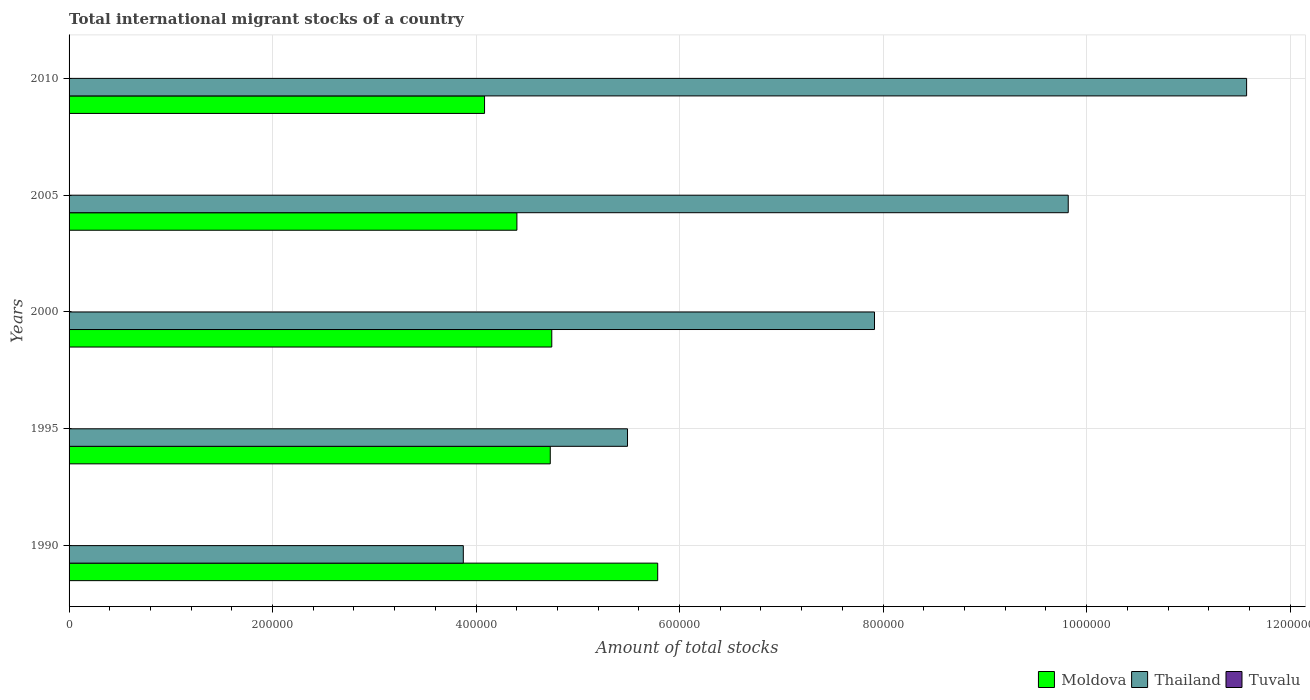How many different coloured bars are there?
Offer a terse response. 3. How many bars are there on the 4th tick from the top?
Your answer should be very brief. 3. How many bars are there on the 1st tick from the bottom?
Give a very brief answer. 3. What is the label of the 5th group of bars from the top?
Give a very brief answer. 1990. In how many cases, is the number of bars for a given year not equal to the number of legend labels?
Ensure brevity in your answer.  0. What is the amount of total stocks in in Thailand in 2000?
Your answer should be very brief. 7.92e+05. Across all years, what is the maximum amount of total stocks in in Thailand?
Offer a terse response. 1.16e+06. Across all years, what is the minimum amount of total stocks in in Moldova?
Provide a succinct answer. 4.08e+05. In which year was the amount of total stocks in in Tuvalu maximum?
Your answer should be very brief. 1990. In which year was the amount of total stocks in in Moldova minimum?
Keep it short and to the point. 2010. What is the total amount of total stocks in in Thailand in the graph?
Ensure brevity in your answer.  3.87e+06. What is the difference between the amount of total stocks in in Thailand in 2000 and that in 2010?
Provide a short and direct response. -3.66e+05. What is the difference between the amount of total stocks in in Tuvalu in 2010 and the amount of total stocks in in Thailand in 1995?
Your answer should be very brief. -5.49e+05. What is the average amount of total stocks in in Moldova per year?
Offer a terse response. 4.75e+05. In the year 1995, what is the difference between the amount of total stocks in in Thailand and amount of total stocks in in Tuvalu?
Make the answer very short. 5.49e+05. In how many years, is the amount of total stocks in in Thailand greater than 120000 ?
Provide a succinct answer. 5. What is the ratio of the amount of total stocks in in Thailand in 1995 to that in 2010?
Offer a terse response. 0.47. Is the amount of total stocks in in Moldova in 1990 less than that in 2000?
Give a very brief answer. No. What is the difference between the highest and the second highest amount of total stocks in in Thailand?
Offer a very short reply. 1.75e+05. What is the difference between the highest and the lowest amount of total stocks in in Tuvalu?
Provide a short and direct response. 172. In how many years, is the amount of total stocks in in Tuvalu greater than the average amount of total stocks in in Tuvalu taken over all years?
Offer a terse response. 2. What does the 3rd bar from the top in 2010 represents?
Ensure brevity in your answer.  Moldova. What does the 1st bar from the bottom in 1990 represents?
Provide a short and direct response. Moldova. Is it the case that in every year, the sum of the amount of total stocks in in Thailand and amount of total stocks in in Tuvalu is greater than the amount of total stocks in in Moldova?
Ensure brevity in your answer.  No. How many bars are there?
Make the answer very short. 15. Are all the bars in the graph horizontal?
Keep it short and to the point. Yes. How many years are there in the graph?
Offer a very short reply. 5. What is the difference between two consecutive major ticks on the X-axis?
Offer a very short reply. 2.00e+05. Are the values on the major ticks of X-axis written in scientific E-notation?
Make the answer very short. No. Does the graph contain any zero values?
Provide a succinct answer. No. How many legend labels are there?
Make the answer very short. 3. How are the legend labels stacked?
Provide a short and direct response. Horizontal. What is the title of the graph?
Provide a succinct answer. Total international migrant stocks of a country. What is the label or title of the X-axis?
Offer a terse response. Amount of total stocks. What is the Amount of total stocks in Moldova in 1990?
Give a very brief answer. 5.78e+05. What is the Amount of total stocks in Thailand in 1990?
Keep it short and to the point. 3.87e+05. What is the Amount of total stocks of Tuvalu in 1990?
Keep it short and to the point. 323. What is the Amount of total stocks of Moldova in 1995?
Your response must be concise. 4.73e+05. What is the Amount of total stocks of Thailand in 1995?
Your answer should be compact. 5.49e+05. What is the Amount of total stocks of Tuvalu in 1995?
Give a very brief answer. 267. What is the Amount of total stocks in Moldova in 2000?
Your answer should be compact. 4.74e+05. What is the Amount of total stocks in Thailand in 2000?
Your response must be concise. 7.92e+05. What is the Amount of total stocks of Tuvalu in 2000?
Provide a succinct answer. 221. What is the Amount of total stocks in Moldova in 2005?
Provide a succinct answer. 4.40e+05. What is the Amount of total stocks in Thailand in 2005?
Your answer should be compact. 9.82e+05. What is the Amount of total stocks in Tuvalu in 2005?
Provide a short and direct response. 183. What is the Amount of total stocks of Moldova in 2010?
Your response must be concise. 4.08e+05. What is the Amount of total stocks in Thailand in 2010?
Ensure brevity in your answer.  1.16e+06. What is the Amount of total stocks in Tuvalu in 2010?
Provide a short and direct response. 151. Across all years, what is the maximum Amount of total stocks in Moldova?
Your response must be concise. 5.78e+05. Across all years, what is the maximum Amount of total stocks in Thailand?
Ensure brevity in your answer.  1.16e+06. Across all years, what is the maximum Amount of total stocks of Tuvalu?
Offer a terse response. 323. Across all years, what is the minimum Amount of total stocks of Moldova?
Ensure brevity in your answer.  4.08e+05. Across all years, what is the minimum Amount of total stocks in Thailand?
Ensure brevity in your answer.  3.87e+05. Across all years, what is the minimum Amount of total stocks in Tuvalu?
Offer a terse response. 151. What is the total Amount of total stocks of Moldova in the graph?
Your answer should be compact. 2.37e+06. What is the total Amount of total stocks in Thailand in the graph?
Your answer should be very brief. 3.87e+06. What is the total Amount of total stocks in Tuvalu in the graph?
Make the answer very short. 1145. What is the difference between the Amount of total stocks of Moldova in 1990 and that in 1995?
Give a very brief answer. 1.06e+05. What is the difference between the Amount of total stocks in Thailand in 1990 and that in 1995?
Offer a terse response. -1.61e+05. What is the difference between the Amount of total stocks in Tuvalu in 1990 and that in 1995?
Give a very brief answer. 56. What is the difference between the Amount of total stocks in Moldova in 1990 and that in 2000?
Provide a short and direct response. 1.04e+05. What is the difference between the Amount of total stocks of Thailand in 1990 and that in 2000?
Offer a terse response. -4.04e+05. What is the difference between the Amount of total stocks in Tuvalu in 1990 and that in 2000?
Keep it short and to the point. 102. What is the difference between the Amount of total stocks in Moldova in 1990 and that in 2005?
Give a very brief answer. 1.38e+05. What is the difference between the Amount of total stocks of Thailand in 1990 and that in 2005?
Your answer should be very brief. -5.95e+05. What is the difference between the Amount of total stocks in Tuvalu in 1990 and that in 2005?
Offer a terse response. 140. What is the difference between the Amount of total stocks in Moldova in 1990 and that in 2010?
Your answer should be very brief. 1.70e+05. What is the difference between the Amount of total stocks of Thailand in 1990 and that in 2010?
Your response must be concise. -7.70e+05. What is the difference between the Amount of total stocks of Tuvalu in 1990 and that in 2010?
Ensure brevity in your answer.  172. What is the difference between the Amount of total stocks in Moldova in 1995 and that in 2000?
Keep it short and to the point. -1500. What is the difference between the Amount of total stocks of Thailand in 1995 and that in 2000?
Offer a terse response. -2.43e+05. What is the difference between the Amount of total stocks of Moldova in 1995 and that in 2005?
Your response must be concise. 3.28e+04. What is the difference between the Amount of total stocks of Thailand in 1995 and that in 2005?
Make the answer very short. -4.33e+05. What is the difference between the Amount of total stocks in Tuvalu in 1995 and that in 2005?
Make the answer very short. 84. What is the difference between the Amount of total stocks in Moldova in 1995 and that in 2010?
Make the answer very short. 6.46e+04. What is the difference between the Amount of total stocks in Thailand in 1995 and that in 2010?
Offer a very short reply. -6.08e+05. What is the difference between the Amount of total stocks in Tuvalu in 1995 and that in 2010?
Ensure brevity in your answer.  116. What is the difference between the Amount of total stocks in Moldova in 2000 and that in 2005?
Give a very brief answer. 3.43e+04. What is the difference between the Amount of total stocks in Thailand in 2000 and that in 2005?
Provide a succinct answer. -1.90e+05. What is the difference between the Amount of total stocks in Moldova in 2000 and that in 2010?
Ensure brevity in your answer.  6.61e+04. What is the difference between the Amount of total stocks of Thailand in 2000 and that in 2010?
Your answer should be compact. -3.66e+05. What is the difference between the Amount of total stocks of Moldova in 2005 and that in 2010?
Ensure brevity in your answer.  3.18e+04. What is the difference between the Amount of total stocks of Thailand in 2005 and that in 2010?
Offer a very short reply. -1.75e+05. What is the difference between the Amount of total stocks in Tuvalu in 2005 and that in 2010?
Provide a short and direct response. 32. What is the difference between the Amount of total stocks in Moldova in 1990 and the Amount of total stocks in Thailand in 1995?
Your answer should be compact. 2.97e+04. What is the difference between the Amount of total stocks of Moldova in 1990 and the Amount of total stocks of Tuvalu in 1995?
Offer a terse response. 5.78e+05. What is the difference between the Amount of total stocks in Thailand in 1990 and the Amount of total stocks in Tuvalu in 1995?
Offer a very short reply. 3.87e+05. What is the difference between the Amount of total stocks of Moldova in 1990 and the Amount of total stocks of Thailand in 2000?
Offer a very short reply. -2.13e+05. What is the difference between the Amount of total stocks in Moldova in 1990 and the Amount of total stocks in Tuvalu in 2000?
Make the answer very short. 5.78e+05. What is the difference between the Amount of total stocks of Thailand in 1990 and the Amount of total stocks of Tuvalu in 2000?
Keep it short and to the point. 3.87e+05. What is the difference between the Amount of total stocks in Moldova in 1990 and the Amount of total stocks in Thailand in 2005?
Offer a terse response. -4.03e+05. What is the difference between the Amount of total stocks in Moldova in 1990 and the Amount of total stocks in Tuvalu in 2005?
Provide a short and direct response. 5.78e+05. What is the difference between the Amount of total stocks in Thailand in 1990 and the Amount of total stocks in Tuvalu in 2005?
Provide a succinct answer. 3.87e+05. What is the difference between the Amount of total stocks of Moldova in 1990 and the Amount of total stocks of Thailand in 2010?
Your answer should be very brief. -5.79e+05. What is the difference between the Amount of total stocks in Moldova in 1990 and the Amount of total stocks in Tuvalu in 2010?
Ensure brevity in your answer.  5.78e+05. What is the difference between the Amount of total stocks in Thailand in 1990 and the Amount of total stocks in Tuvalu in 2010?
Offer a very short reply. 3.87e+05. What is the difference between the Amount of total stocks in Moldova in 1995 and the Amount of total stocks in Thailand in 2000?
Offer a terse response. -3.19e+05. What is the difference between the Amount of total stocks of Moldova in 1995 and the Amount of total stocks of Tuvalu in 2000?
Give a very brief answer. 4.73e+05. What is the difference between the Amount of total stocks in Thailand in 1995 and the Amount of total stocks in Tuvalu in 2000?
Your answer should be compact. 5.49e+05. What is the difference between the Amount of total stocks of Moldova in 1995 and the Amount of total stocks of Thailand in 2005?
Your answer should be very brief. -5.09e+05. What is the difference between the Amount of total stocks in Moldova in 1995 and the Amount of total stocks in Tuvalu in 2005?
Give a very brief answer. 4.73e+05. What is the difference between the Amount of total stocks of Thailand in 1995 and the Amount of total stocks of Tuvalu in 2005?
Provide a short and direct response. 5.49e+05. What is the difference between the Amount of total stocks of Moldova in 1995 and the Amount of total stocks of Thailand in 2010?
Provide a short and direct response. -6.84e+05. What is the difference between the Amount of total stocks of Moldova in 1995 and the Amount of total stocks of Tuvalu in 2010?
Offer a very short reply. 4.73e+05. What is the difference between the Amount of total stocks in Thailand in 1995 and the Amount of total stocks in Tuvalu in 2010?
Offer a very short reply. 5.49e+05. What is the difference between the Amount of total stocks in Moldova in 2000 and the Amount of total stocks in Thailand in 2005?
Provide a succinct answer. -5.08e+05. What is the difference between the Amount of total stocks in Moldova in 2000 and the Amount of total stocks in Tuvalu in 2005?
Offer a very short reply. 4.74e+05. What is the difference between the Amount of total stocks in Thailand in 2000 and the Amount of total stocks in Tuvalu in 2005?
Offer a very short reply. 7.91e+05. What is the difference between the Amount of total stocks in Moldova in 2000 and the Amount of total stocks in Thailand in 2010?
Make the answer very short. -6.83e+05. What is the difference between the Amount of total stocks in Moldova in 2000 and the Amount of total stocks in Tuvalu in 2010?
Make the answer very short. 4.74e+05. What is the difference between the Amount of total stocks in Thailand in 2000 and the Amount of total stocks in Tuvalu in 2010?
Your response must be concise. 7.91e+05. What is the difference between the Amount of total stocks in Moldova in 2005 and the Amount of total stocks in Thailand in 2010?
Provide a succinct answer. -7.17e+05. What is the difference between the Amount of total stocks of Moldova in 2005 and the Amount of total stocks of Tuvalu in 2010?
Your answer should be very brief. 4.40e+05. What is the difference between the Amount of total stocks in Thailand in 2005 and the Amount of total stocks in Tuvalu in 2010?
Your answer should be very brief. 9.82e+05. What is the average Amount of total stocks in Moldova per year?
Keep it short and to the point. 4.75e+05. What is the average Amount of total stocks of Thailand per year?
Keep it short and to the point. 7.73e+05. What is the average Amount of total stocks of Tuvalu per year?
Keep it short and to the point. 229. In the year 1990, what is the difference between the Amount of total stocks in Moldova and Amount of total stocks in Thailand?
Your answer should be very brief. 1.91e+05. In the year 1990, what is the difference between the Amount of total stocks in Moldova and Amount of total stocks in Tuvalu?
Provide a succinct answer. 5.78e+05. In the year 1990, what is the difference between the Amount of total stocks in Thailand and Amount of total stocks in Tuvalu?
Your answer should be very brief. 3.87e+05. In the year 1995, what is the difference between the Amount of total stocks in Moldova and Amount of total stocks in Thailand?
Provide a short and direct response. -7.59e+04. In the year 1995, what is the difference between the Amount of total stocks of Moldova and Amount of total stocks of Tuvalu?
Your response must be concise. 4.73e+05. In the year 1995, what is the difference between the Amount of total stocks of Thailand and Amount of total stocks of Tuvalu?
Your answer should be very brief. 5.49e+05. In the year 2000, what is the difference between the Amount of total stocks of Moldova and Amount of total stocks of Thailand?
Your answer should be very brief. -3.17e+05. In the year 2000, what is the difference between the Amount of total stocks in Moldova and Amount of total stocks in Tuvalu?
Your answer should be compact. 4.74e+05. In the year 2000, what is the difference between the Amount of total stocks of Thailand and Amount of total stocks of Tuvalu?
Your response must be concise. 7.91e+05. In the year 2005, what is the difference between the Amount of total stocks in Moldova and Amount of total stocks in Thailand?
Your answer should be very brief. -5.42e+05. In the year 2005, what is the difference between the Amount of total stocks of Moldova and Amount of total stocks of Tuvalu?
Keep it short and to the point. 4.40e+05. In the year 2005, what is the difference between the Amount of total stocks of Thailand and Amount of total stocks of Tuvalu?
Offer a terse response. 9.82e+05. In the year 2010, what is the difference between the Amount of total stocks in Moldova and Amount of total stocks in Thailand?
Provide a short and direct response. -7.49e+05. In the year 2010, what is the difference between the Amount of total stocks of Moldova and Amount of total stocks of Tuvalu?
Ensure brevity in your answer.  4.08e+05. In the year 2010, what is the difference between the Amount of total stocks in Thailand and Amount of total stocks in Tuvalu?
Your answer should be compact. 1.16e+06. What is the ratio of the Amount of total stocks in Moldova in 1990 to that in 1995?
Your answer should be compact. 1.22. What is the ratio of the Amount of total stocks in Thailand in 1990 to that in 1995?
Provide a short and direct response. 0.71. What is the ratio of the Amount of total stocks of Tuvalu in 1990 to that in 1995?
Offer a very short reply. 1.21. What is the ratio of the Amount of total stocks of Moldova in 1990 to that in 2000?
Provide a short and direct response. 1.22. What is the ratio of the Amount of total stocks of Thailand in 1990 to that in 2000?
Offer a terse response. 0.49. What is the ratio of the Amount of total stocks in Tuvalu in 1990 to that in 2000?
Provide a short and direct response. 1.46. What is the ratio of the Amount of total stocks of Moldova in 1990 to that in 2005?
Your response must be concise. 1.31. What is the ratio of the Amount of total stocks of Thailand in 1990 to that in 2005?
Give a very brief answer. 0.39. What is the ratio of the Amount of total stocks of Tuvalu in 1990 to that in 2005?
Offer a terse response. 1.76. What is the ratio of the Amount of total stocks of Moldova in 1990 to that in 2010?
Keep it short and to the point. 1.42. What is the ratio of the Amount of total stocks in Thailand in 1990 to that in 2010?
Your answer should be compact. 0.33. What is the ratio of the Amount of total stocks in Tuvalu in 1990 to that in 2010?
Give a very brief answer. 2.14. What is the ratio of the Amount of total stocks of Thailand in 1995 to that in 2000?
Provide a short and direct response. 0.69. What is the ratio of the Amount of total stocks of Tuvalu in 1995 to that in 2000?
Provide a short and direct response. 1.21. What is the ratio of the Amount of total stocks of Moldova in 1995 to that in 2005?
Offer a very short reply. 1.07. What is the ratio of the Amount of total stocks of Thailand in 1995 to that in 2005?
Provide a short and direct response. 0.56. What is the ratio of the Amount of total stocks in Tuvalu in 1995 to that in 2005?
Offer a very short reply. 1.46. What is the ratio of the Amount of total stocks in Moldova in 1995 to that in 2010?
Offer a very short reply. 1.16. What is the ratio of the Amount of total stocks in Thailand in 1995 to that in 2010?
Offer a very short reply. 0.47. What is the ratio of the Amount of total stocks in Tuvalu in 1995 to that in 2010?
Provide a short and direct response. 1.77. What is the ratio of the Amount of total stocks of Moldova in 2000 to that in 2005?
Make the answer very short. 1.08. What is the ratio of the Amount of total stocks in Thailand in 2000 to that in 2005?
Provide a succinct answer. 0.81. What is the ratio of the Amount of total stocks of Tuvalu in 2000 to that in 2005?
Keep it short and to the point. 1.21. What is the ratio of the Amount of total stocks in Moldova in 2000 to that in 2010?
Make the answer very short. 1.16. What is the ratio of the Amount of total stocks in Thailand in 2000 to that in 2010?
Give a very brief answer. 0.68. What is the ratio of the Amount of total stocks in Tuvalu in 2000 to that in 2010?
Your answer should be compact. 1.46. What is the ratio of the Amount of total stocks in Moldova in 2005 to that in 2010?
Provide a short and direct response. 1.08. What is the ratio of the Amount of total stocks in Thailand in 2005 to that in 2010?
Provide a short and direct response. 0.85. What is the ratio of the Amount of total stocks of Tuvalu in 2005 to that in 2010?
Provide a short and direct response. 1.21. What is the difference between the highest and the second highest Amount of total stocks of Moldova?
Make the answer very short. 1.04e+05. What is the difference between the highest and the second highest Amount of total stocks of Thailand?
Keep it short and to the point. 1.75e+05. What is the difference between the highest and the second highest Amount of total stocks of Tuvalu?
Offer a very short reply. 56. What is the difference between the highest and the lowest Amount of total stocks of Moldova?
Give a very brief answer. 1.70e+05. What is the difference between the highest and the lowest Amount of total stocks of Thailand?
Offer a very short reply. 7.70e+05. What is the difference between the highest and the lowest Amount of total stocks in Tuvalu?
Offer a terse response. 172. 